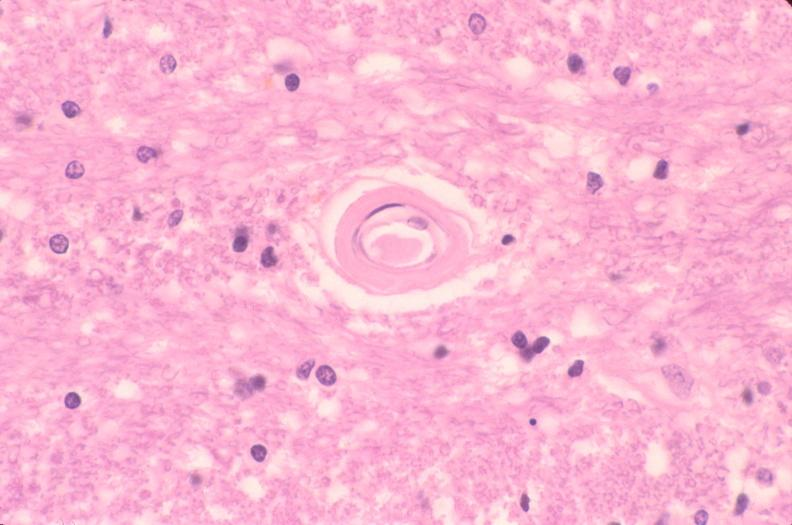what is present?
Answer the question using a single word or phrase. Nervous 